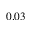Convert formula to latex. <formula><loc_0><loc_0><loc_500><loc_500>0 . 0 3</formula> 